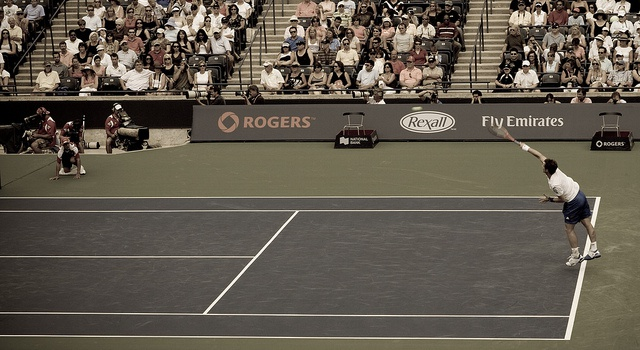Describe the objects in this image and their specific colors. I can see people in black, gray, darkgray, and lightgray tones, people in black, lightgray, darkgray, and gray tones, people in black, tan, and gray tones, people in black, tan, and gray tones, and people in black, tan, and gray tones in this image. 